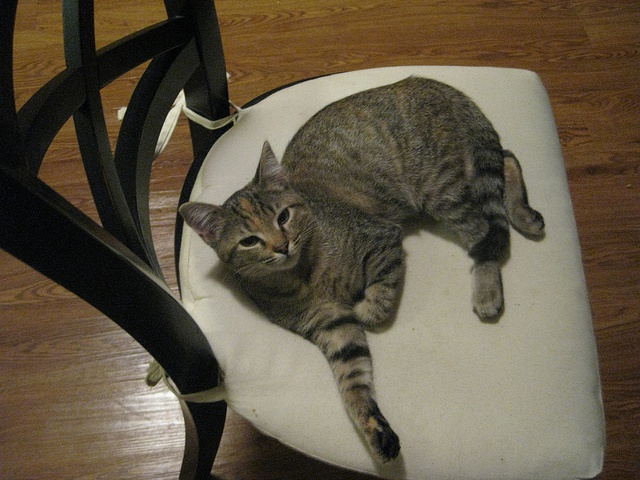Describe the objects in this image and their specific colors. I can see chair in black, darkgray, and gray tones and cat in black, darkgreen, and gray tones in this image. 